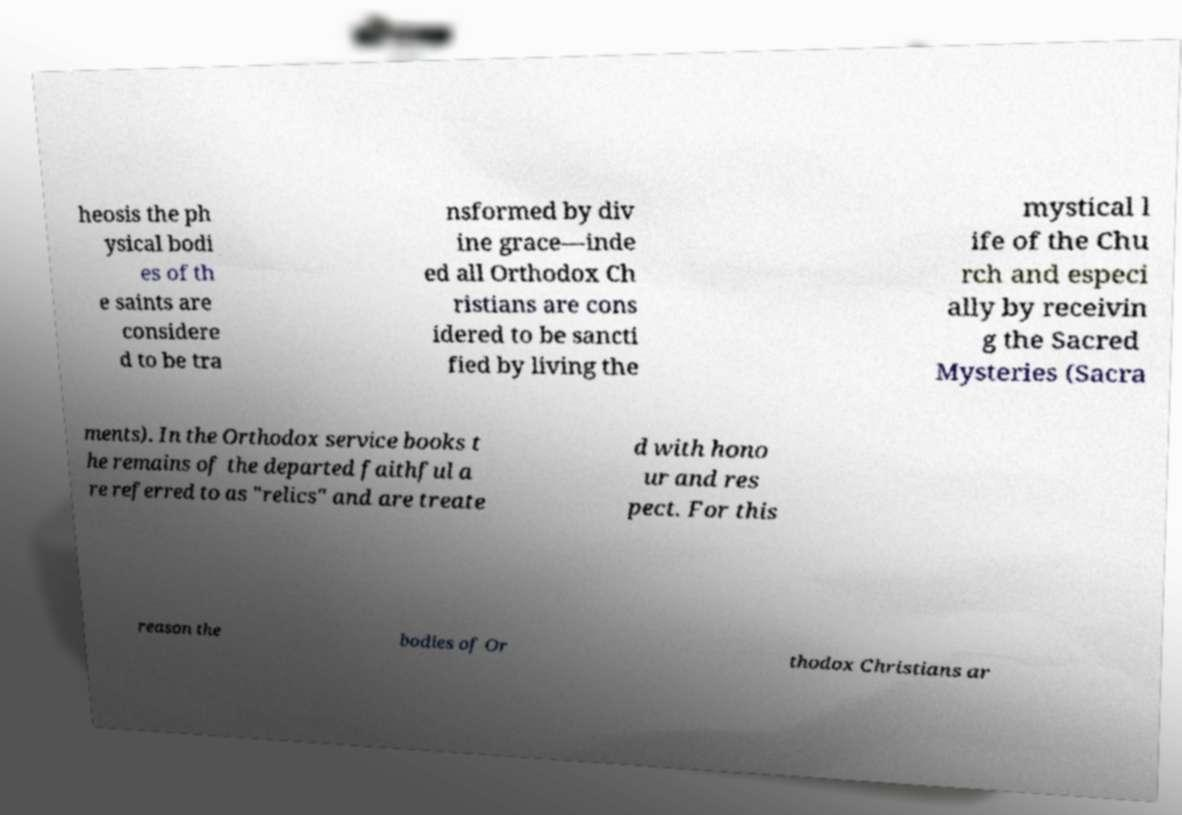Can you accurately transcribe the text from the provided image for me? heosis the ph ysical bodi es of th e saints are considere d to be tra nsformed by div ine grace—inde ed all Orthodox Ch ristians are cons idered to be sancti fied by living the mystical l ife of the Chu rch and especi ally by receivin g the Sacred Mysteries (Sacra ments). In the Orthodox service books t he remains of the departed faithful a re referred to as "relics" and are treate d with hono ur and res pect. For this reason the bodies of Or thodox Christians ar 